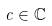<formula> <loc_0><loc_0><loc_500><loc_500>c \in { \mathbb { C } }</formula> 